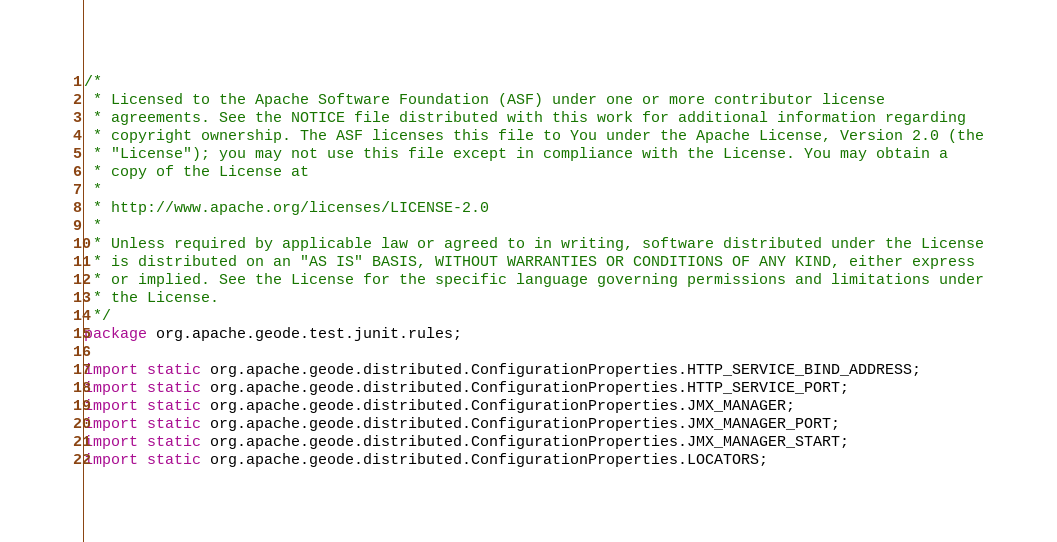Convert code to text. <code><loc_0><loc_0><loc_500><loc_500><_Java_>/*
 * Licensed to the Apache Software Foundation (ASF) under one or more contributor license
 * agreements. See the NOTICE file distributed with this work for additional information regarding
 * copyright ownership. The ASF licenses this file to You under the Apache License, Version 2.0 (the
 * "License"); you may not use this file except in compliance with the License. You may obtain a
 * copy of the License at
 *
 * http://www.apache.org/licenses/LICENSE-2.0
 *
 * Unless required by applicable law or agreed to in writing, software distributed under the License
 * is distributed on an "AS IS" BASIS, WITHOUT WARRANTIES OR CONDITIONS OF ANY KIND, either express
 * or implied. See the License for the specific language governing permissions and limitations under
 * the License.
 */
package org.apache.geode.test.junit.rules;

import static org.apache.geode.distributed.ConfigurationProperties.HTTP_SERVICE_BIND_ADDRESS;
import static org.apache.geode.distributed.ConfigurationProperties.HTTP_SERVICE_PORT;
import static org.apache.geode.distributed.ConfigurationProperties.JMX_MANAGER;
import static org.apache.geode.distributed.ConfigurationProperties.JMX_MANAGER_PORT;
import static org.apache.geode.distributed.ConfigurationProperties.JMX_MANAGER_START;
import static org.apache.geode.distributed.ConfigurationProperties.LOCATORS;</code> 